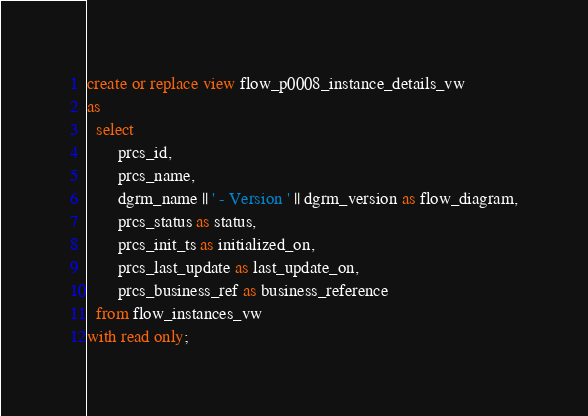Convert code to text. <code><loc_0><loc_0><loc_500><loc_500><_SQL_>create or replace view flow_p0008_instance_details_vw
as
  select 
       prcs_id,
       prcs_name,
       dgrm_name || ' - Version ' || dgrm_version as flow_diagram,
       prcs_status as status,
       prcs_init_ts as initialized_on,
       prcs_last_update as last_update_on,
       prcs_business_ref as business_reference
  from flow_instances_vw
with read only;
</code> 